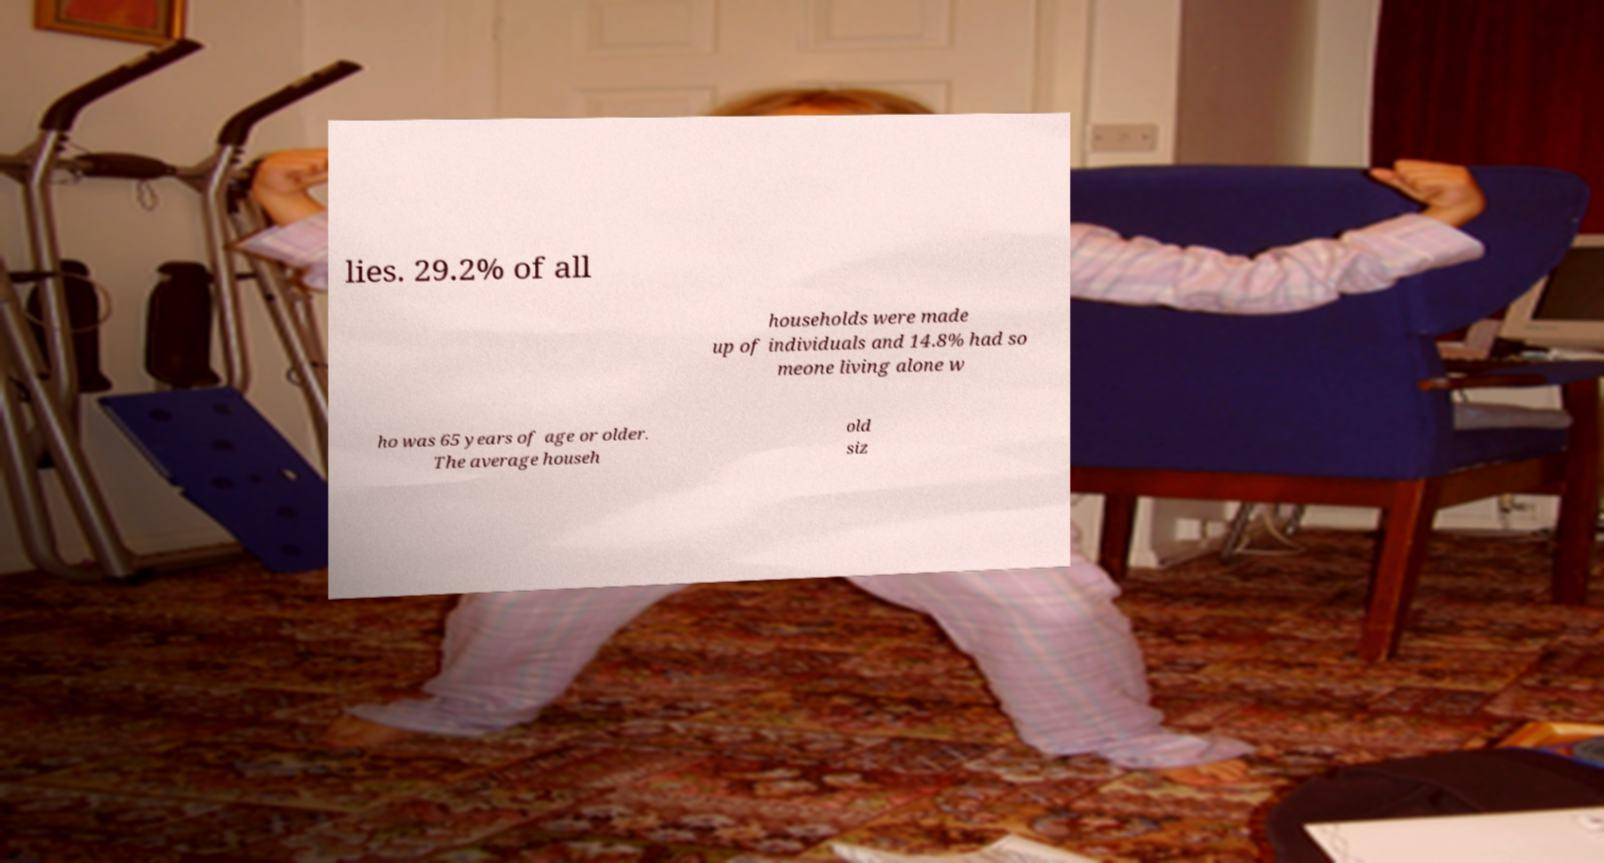I need the written content from this picture converted into text. Can you do that? lies. 29.2% of all households were made up of individuals and 14.8% had so meone living alone w ho was 65 years of age or older. The average househ old siz 